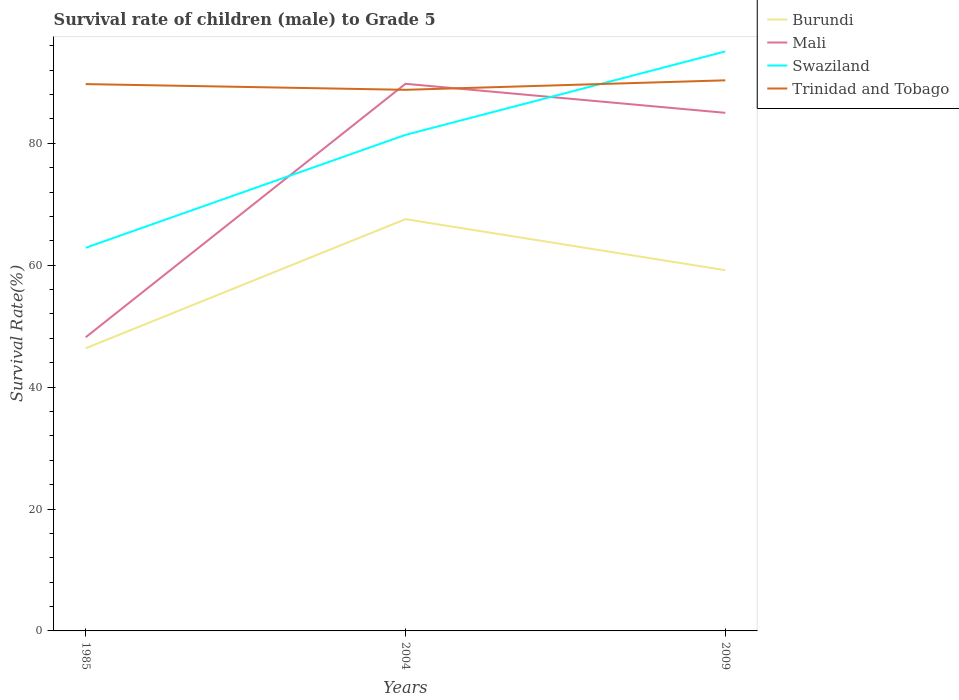How many different coloured lines are there?
Keep it short and to the point. 4. Across all years, what is the maximum survival rate of male children to grade 5 in Swaziland?
Keep it short and to the point. 62.87. In which year was the survival rate of male children to grade 5 in Swaziland maximum?
Ensure brevity in your answer.  1985. What is the total survival rate of male children to grade 5 in Trinidad and Tobago in the graph?
Make the answer very short. -1.56. What is the difference between the highest and the second highest survival rate of male children to grade 5 in Burundi?
Your answer should be compact. 21.18. What is the difference between the highest and the lowest survival rate of male children to grade 5 in Swaziland?
Your answer should be compact. 2. What is the difference between two consecutive major ticks on the Y-axis?
Ensure brevity in your answer.  20. Does the graph contain any zero values?
Keep it short and to the point. No. How are the legend labels stacked?
Your answer should be compact. Vertical. What is the title of the graph?
Your answer should be very brief. Survival rate of children (male) to Grade 5. Does "Bahamas" appear as one of the legend labels in the graph?
Your answer should be very brief. No. What is the label or title of the X-axis?
Give a very brief answer. Years. What is the label or title of the Y-axis?
Your answer should be very brief. Survival Rate(%). What is the Survival Rate(%) in Burundi in 1985?
Ensure brevity in your answer.  46.38. What is the Survival Rate(%) of Mali in 1985?
Your response must be concise. 48.18. What is the Survival Rate(%) of Swaziland in 1985?
Give a very brief answer. 62.87. What is the Survival Rate(%) in Trinidad and Tobago in 1985?
Offer a very short reply. 89.72. What is the Survival Rate(%) in Burundi in 2004?
Make the answer very short. 67.56. What is the Survival Rate(%) in Mali in 2004?
Your answer should be very brief. 89.77. What is the Survival Rate(%) in Swaziland in 2004?
Your answer should be very brief. 81.39. What is the Survival Rate(%) of Trinidad and Tobago in 2004?
Keep it short and to the point. 88.78. What is the Survival Rate(%) of Burundi in 2009?
Give a very brief answer. 59.19. What is the Survival Rate(%) of Mali in 2009?
Give a very brief answer. 85.01. What is the Survival Rate(%) in Swaziland in 2009?
Provide a short and direct response. 95.08. What is the Survival Rate(%) of Trinidad and Tobago in 2009?
Make the answer very short. 90.34. Across all years, what is the maximum Survival Rate(%) of Burundi?
Your response must be concise. 67.56. Across all years, what is the maximum Survival Rate(%) in Mali?
Provide a short and direct response. 89.77. Across all years, what is the maximum Survival Rate(%) of Swaziland?
Your answer should be very brief. 95.08. Across all years, what is the maximum Survival Rate(%) in Trinidad and Tobago?
Provide a short and direct response. 90.34. Across all years, what is the minimum Survival Rate(%) in Burundi?
Offer a terse response. 46.38. Across all years, what is the minimum Survival Rate(%) of Mali?
Provide a short and direct response. 48.18. Across all years, what is the minimum Survival Rate(%) in Swaziland?
Give a very brief answer. 62.87. Across all years, what is the minimum Survival Rate(%) in Trinidad and Tobago?
Make the answer very short. 88.78. What is the total Survival Rate(%) in Burundi in the graph?
Your response must be concise. 173.13. What is the total Survival Rate(%) of Mali in the graph?
Offer a terse response. 222.96. What is the total Survival Rate(%) of Swaziland in the graph?
Offer a terse response. 239.34. What is the total Survival Rate(%) in Trinidad and Tobago in the graph?
Make the answer very short. 268.85. What is the difference between the Survival Rate(%) in Burundi in 1985 and that in 2004?
Provide a succinct answer. -21.18. What is the difference between the Survival Rate(%) in Mali in 1985 and that in 2004?
Give a very brief answer. -41.59. What is the difference between the Survival Rate(%) in Swaziland in 1985 and that in 2004?
Your answer should be compact. -18.52. What is the difference between the Survival Rate(%) in Trinidad and Tobago in 1985 and that in 2004?
Ensure brevity in your answer.  0.94. What is the difference between the Survival Rate(%) in Burundi in 1985 and that in 2009?
Provide a succinct answer. -12.81. What is the difference between the Survival Rate(%) in Mali in 1985 and that in 2009?
Provide a succinct answer. -36.83. What is the difference between the Survival Rate(%) of Swaziland in 1985 and that in 2009?
Offer a very short reply. -32.22. What is the difference between the Survival Rate(%) in Trinidad and Tobago in 1985 and that in 2009?
Keep it short and to the point. -0.62. What is the difference between the Survival Rate(%) of Burundi in 2004 and that in 2009?
Offer a terse response. 8.37. What is the difference between the Survival Rate(%) in Mali in 2004 and that in 2009?
Your answer should be compact. 4.76. What is the difference between the Survival Rate(%) in Swaziland in 2004 and that in 2009?
Your answer should be very brief. -13.7. What is the difference between the Survival Rate(%) of Trinidad and Tobago in 2004 and that in 2009?
Your response must be concise. -1.56. What is the difference between the Survival Rate(%) of Burundi in 1985 and the Survival Rate(%) of Mali in 2004?
Offer a very short reply. -43.39. What is the difference between the Survival Rate(%) of Burundi in 1985 and the Survival Rate(%) of Swaziland in 2004?
Make the answer very short. -35.01. What is the difference between the Survival Rate(%) of Burundi in 1985 and the Survival Rate(%) of Trinidad and Tobago in 2004?
Keep it short and to the point. -42.4. What is the difference between the Survival Rate(%) of Mali in 1985 and the Survival Rate(%) of Swaziland in 2004?
Ensure brevity in your answer.  -33.21. What is the difference between the Survival Rate(%) of Mali in 1985 and the Survival Rate(%) of Trinidad and Tobago in 2004?
Keep it short and to the point. -40.6. What is the difference between the Survival Rate(%) in Swaziland in 1985 and the Survival Rate(%) in Trinidad and Tobago in 2004?
Your answer should be very brief. -25.92. What is the difference between the Survival Rate(%) of Burundi in 1985 and the Survival Rate(%) of Mali in 2009?
Provide a succinct answer. -38.63. What is the difference between the Survival Rate(%) of Burundi in 1985 and the Survival Rate(%) of Swaziland in 2009?
Keep it short and to the point. -48.7. What is the difference between the Survival Rate(%) in Burundi in 1985 and the Survival Rate(%) in Trinidad and Tobago in 2009?
Your response must be concise. -43.96. What is the difference between the Survival Rate(%) of Mali in 1985 and the Survival Rate(%) of Swaziland in 2009?
Provide a short and direct response. -46.9. What is the difference between the Survival Rate(%) of Mali in 1985 and the Survival Rate(%) of Trinidad and Tobago in 2009?
Your response must be concise. -42.16. What is the difference between the Survival Rate(%) of Swaziland in 1985 and the Survival Rate(%) of Trinidad and Tobago in 2009?
Ensure brevity in your answer.  -27.47. What is the difference between the Survival Rate(%) in Burundi in 2004 and the Survival Rate(%) in Mali in 2009?
Provide a succinct answer. -17.45. What is the difference between the Survival Rate(%) in Burundi in 2004 and the Survival Rate(%) in Swaziland in 2009?
Provide a short and direct response. -27.52. What is the difference between the Survival Rate(%) in Burundi in 2004 and the Survival Rate(%) in Trinidad and Tobago in 2009?
Your answer should be very brief. -22.78. What is the difference between the Survival Rate(%) in Mali in 2004 and the Survival Rate(%) in Swaziland in 2009?
Keep it short and to the point. -5.31. What is the difference between the Survival Rate(%) of Mali in 2004 and the Survival Rate(%) of Trinidad and Tobago in 2009?
Give a very brief answer. -0.57. What is the difference between the Survival Rate(%) in Swaziland in 2004 and the Survival Rate(%) in Trinidad and Tobago in 2009?
Ensure brevity in your answer.  -8.95. What is the average Survival Rate(%) of Burundi per year?
Your answer should be compact. 57.71. What is the average Survival Rate(%) in Mali per year?
Your answer should be very brief. 74.32. What is the average Survival Rate(%) in Swaziland per year?
Give a very brief answer. 79.78. What is the average Survival Rate(%) in Trinidad and Tobago per year?
Offer a very short reply. 89.62. In the year 1985, what is the difference between the Survival Rate(%) of Burundi and Survival Rate(%) of Mali?
Your answer should be very brief. -1.8. In the year 1985, what is the difference between the Survival Rate(%) in Burundi and Survival Rate(%) in Swaziland?
Make the answer very short. -16.49. In the year 1985, what is the difference between the Survival Rate(%) of Burundi and Survival Rate(%) of Trinidad and Tobago?
Offer a very short reply. -43.34. In the year 1985, what is the difference between the Survival Rate(%) of Mali and Survival Rate(%) of Swaziland?
Your answer should be very brief. -14.68. In the year 1985, what is the difference between the Survival Rate(%) in Mali and Survival Rate(%) in Trinidad and Tobago?
Provide a short and direct response. -41.54. In the year 1985, what is the difference between the Survival Rate(%) in Swaziland and Survival Rate(%) in Trinidad and Tobago?
Keep it short and to the point. -26.86. In the year 2004, what is the difference between the Survival Rate(%) in Burundi and Survival Rate(%) in Mali?
Keep it short and to the point. -22.21. In the year 2004, what is the difference between the Survival Rate(%) of Burundi and Survival Rate(%) of Swaziland?
Give a very brief answer. -13.83. In the year 2004, what is the difference between the Survival Rate(%) in Burundi and Survival Rate(%) in Trinidad and Tobago?
Make the answer very short. -21.22. In the year 2004, what is the difference between the Survival Rate(%) in Mali and Survival Rate(%) in Swaziland?
Provide a short and direct response. 8.38. In the year 2004, what is the difference between the Survival Rate(%) of Swaziland and Survival Rate(%) of Trinidad and Tobago?
Provide a short and direct response. -7.4. In the year 2009, what is the difference between the Survival Rate(%) of Burundi and Survival Rate(%) of Mali?
Give a very brief answer. -25.82. In the year 2009, what is the difference between the Survival Rate(%) of Burundi and Survival Rate(%) of Swaziland?
Provide a succinct answer. -35.9. In the year 2009, what is the difference between the Survival Rate(%) of Burundi and Survival Rate(%) of Trinidad and Tobago?
Provide a succinct answer. -31.15. In the year 2009, what is the difference between the Survival Rate(%) of Mali and Survival Rate(%) of Swaziland?
Ensure brevity in your answer.  -10.07. In the year 2009, what is the difference between the Survival Rate(%) of Mali and Survival Rate(%) of Trinidad and Tobago?
Ensure brevity in your answer.  -5.33. In the year 2009, what is the difference between the Survival Rate(%) in Swaziland and Survival Rate(%) in Trinidad and Tobago?
Make the answer very short. 4.74. What is the ratio of the Survival Rate(%) in Burundi in 1985 to that in 2004?
Provide a short and direct response. 0.69. What is the ratio of the Survival Rate(%) in Mali in 1985 to that in 2004?
Make the answer very short. 0.54. What is the ratio of the Survival Rate(%) of Swaziland in 1985 to that in 2004?
Ensure brevity in your answer.  0.77. What is the ratio of the Survival Rate(%) of Trinidad and Tobago in 1985 to that in 2004?
Make the answer very short. 1.01. What is the ratio of the Survival Rate(%) of Burundi in 1985 to that in 2009?
Your answer should be very brief. 0.78. What is the ratio of the Survival Rate(%) of Mali in 1985 to that in 2009?
Provide a short and direct response. 0.57. What is the ratio of the Survival Rate(%) in Swaziland in 1985 to that in 2009?
Offer a terse response. 0.66. What is the ratio of the Survival Rate(%) in Trinidad and Tobago in 1985 to that in 2009?
Keep it short and to the point. 0.99. What is the ratio of the Survival Rate(%) in Burundi in 2004 to that in 2009?
Keep it short and to the point. 1.14. What is the ratio of the Survival Rate(%) in Mali in 2004 to that in 2009?
Offer a very short reply. 1.06. What is the ratio of the Survival Rate(%) in Swaziland in 2004 to that in 2009?
Your answer should be very brief. 0.86. What is the ratio of the Survival Rate(%) in Trinidad and Tobago in 2004 to that in 2009?
Offer a terse response. 0.98. What is the difference between the highest and the second highest Survival Rate(%) of Burundi?
Give a very brief answer. 8.37. What is the difference between the highest and the second highest Survival Rate(%) of Mali?
Provide a short and direct response. 4.76. What is the difference between the highest and the second highest Survival Rate(%) of Swaziland?
Provide a succinct answer. 13.7. What is the difference between the highest and the second highest Survival Rate(%) of Trinidad and Tobago?
Make the answer very short. 0.62. What is the difference between the highest and the lowest Survival Rate(%) of Burundi?
Ensure brevity in your answer.  21.18. What is the difference between the highest and the lowest Survival Rate(%) of Mali?
Offer a very short reply. 41.59. What is the difference between the highest and the lowest Survival Rate(%) in Swaziland?
Your response must be concise. 32.22. What is the difference between the highest and the lowest Survival Rate(%) in Trinidad and Tobago?
Provide a succinct answer. 1.56. 